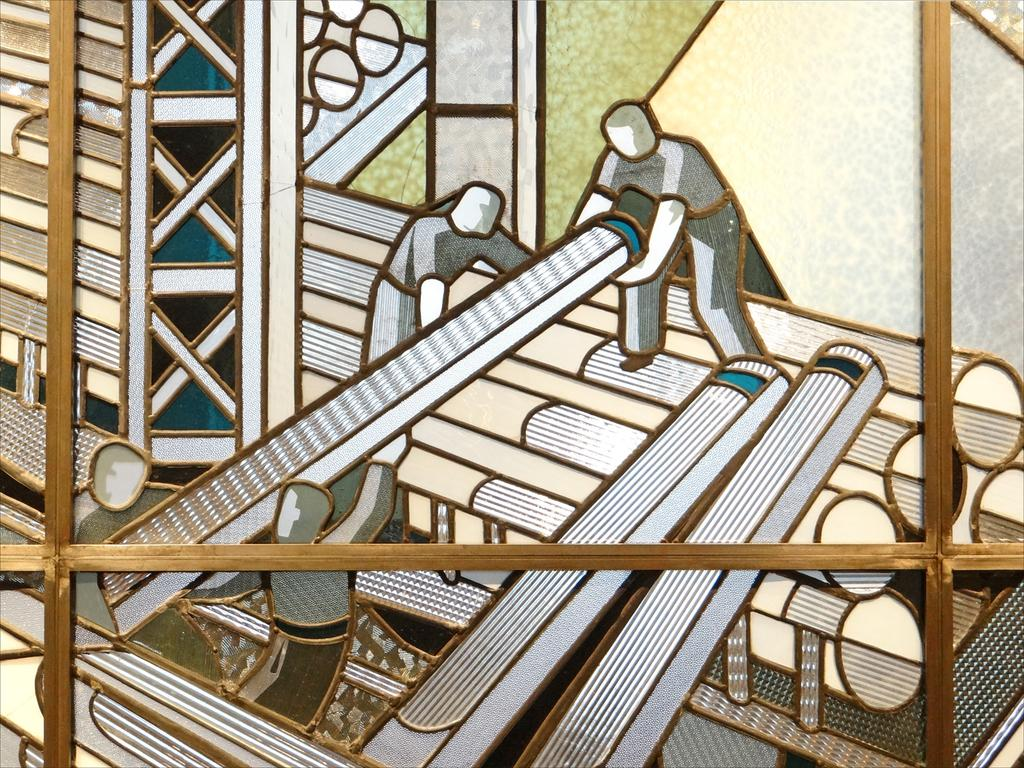What is the main subject of the image? The main subject of the image is a thread craft design on a wooden board. How many people are in the image? There are four persons in the image. What are the people holding in their hands? Each person is holding a long rod in their hand. What type of crown is being worn by the person in the image? There is no crown present in the image; the people are holding long rods in their hands. 